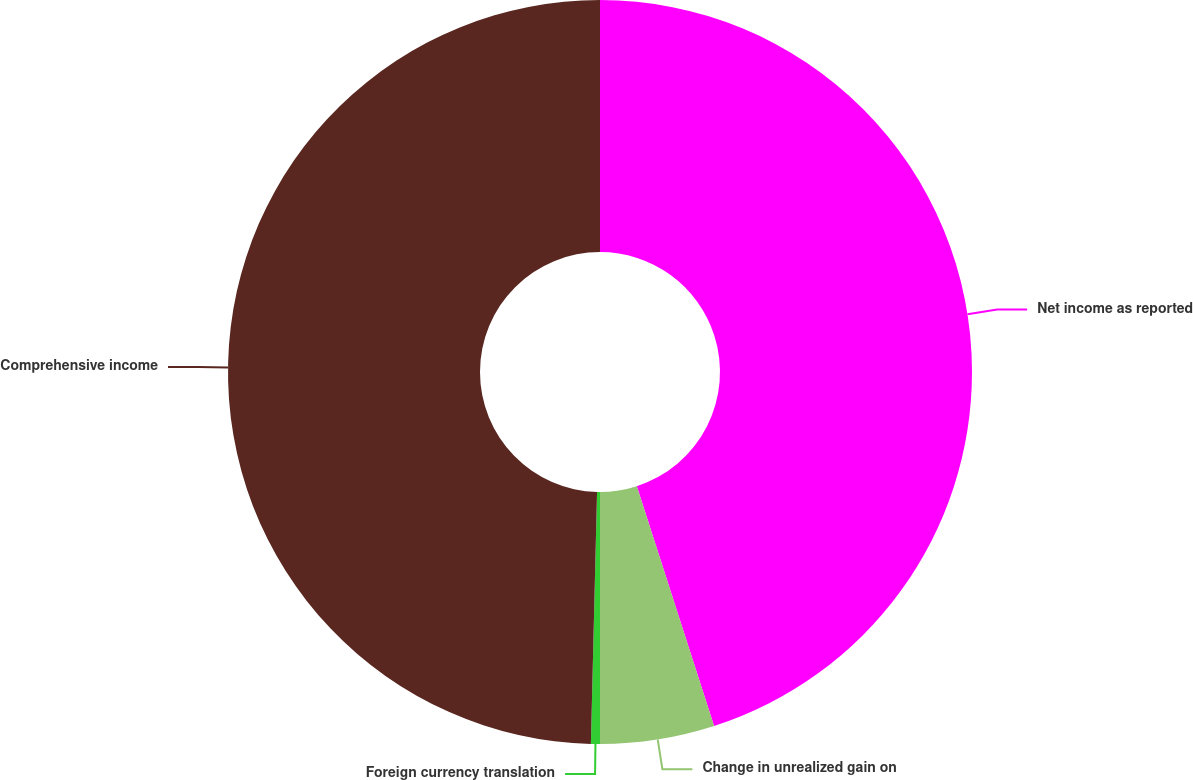Convert chart to OTSL. <chart><loc_0><loc_0><loc_500><loc_500><pie_chart><fcel>Net income as reported<fcel>Change in unrealized gain on<fcel>Foreign currency translation<fcel>Comprehensive income<nl><fcel>45.04%<fcel>4.96%<fcel>0.39%<fcel>49.61%<nl></chart> 